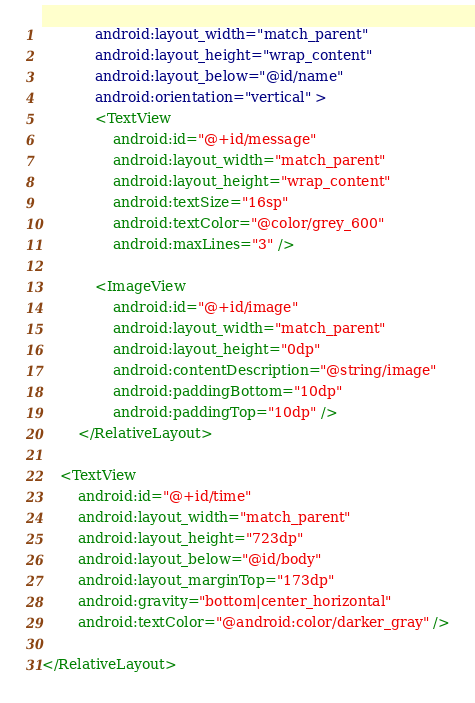Convert code to text. <code><loc_0><loc_0><loc_500><loc_500><_XML_>            android:layout_width="match_parent"
            android:layout_height="wrap_content"
            android:layout_below="@id/name"
            android:orientation="vertical" >
            <TextView
                android:id="@+id/message"
                android:layout_width="match_parent"
                android:layout_height="wrap_content"
                android:textSize="16sp"
                android:textColor="@color/grey_600"
                android:maxLines="3" />

            <ImageView
                android:id="@+id/image"
                android:layout_width="match_parent"
                android:layout_height="0dp"
                android:contentDescription="@string/image"
                android:paddingBottom="10dp"
                android:paddingTop="10dp" />
        </RelativeLayout>

    <TextView
        android:id="@+id/time"
        android:layout_width="match_parent"
        android:layout_height="723dp"
        android:layout_below="@id/body"
        android:layout_marginTop="173dp"
        android:gravity="bottom|center_horizontal"
        android:textColor="@android:color/darker_gray" />

</RelativeLayout></code> 